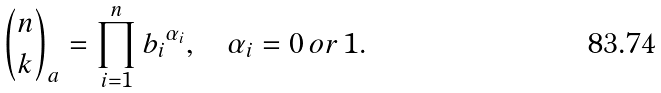<formula> <loc_0><loc_0><loc_500><loc_500>\binom { n } { k } _ { a } = \prod ^ { n } _ { i = 1 } { b _ { i } } ^ { \alpha _ { i } } , \quad \alpha _ { i } = 0 \, o r \, 1 .</formula> 